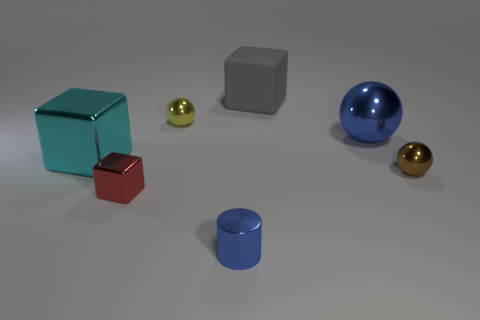Add 2 large brown shiny cylinders. How many objects exist? 9 Subtract all small red blocks. How many blocks are left? 2 Subtract all blue balls. How many balls are left? 2 Subtract 1 gray cubes. How many objects are left? 6 Subtract all spheres. How many objects are left? 4 Subtract 3 blocks. How many blocks are left? 0 Subtract all cyan balls. Subtract all purple cylinders. How many balls are left? 3 Subtract all gray things. Subtract all large gray things. How many objects are left? 5 Add 2 blue metallic cylinders. How many blue metallic cylinders are left? 3 Add 1 brown cubes. How many brown cubes exist? 1 